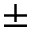<formula> <loc_0><loc_0><loc_500><loc_500>\pm</formula> 